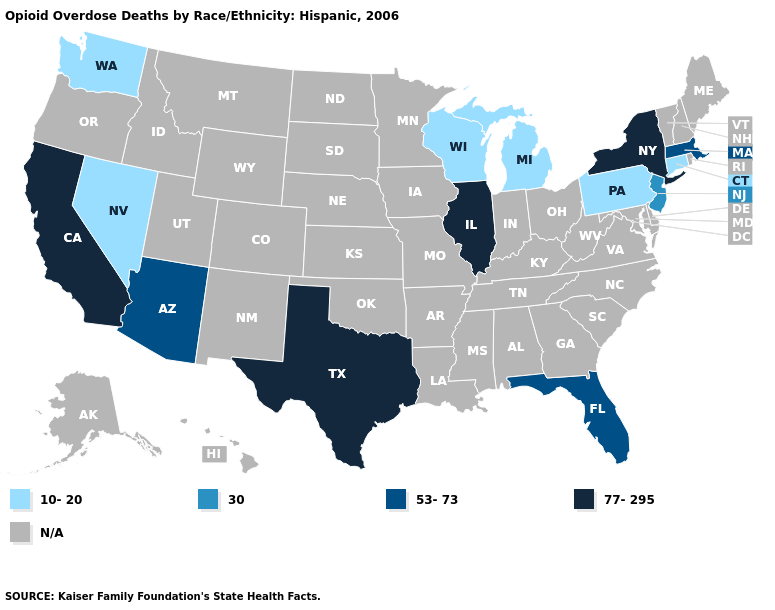What is the value of Wyoming?
Concise answer only. N/A. What is the highest value in the Northeast ?
Concise answer only. 77-295. Does Pennsylvania have the highest value in the USA?
Concise answer only. No. Name the states that have a value in the range 30?
Keep it brief. New Jersey. What is the value of Missouri?
Short answer required. N/A. Which states hav the highest value in the MidWest?
Answer briefly. Illinois. Name the states that have a value in the range 77-295?
Write a very short answer. California, Illinois, New York, Texas. Is the legend a continuous bar?
Write a very short answer. No. What is the highest value in states that border Illinois?
Short answer required. 10-20. Does Washington have the highest value in the USA?
Short answer required. No. Name the states that have a value in the range N/A?
Concise answer only. Alabama, Alaska, Arkansas, Colorado, Delaware, Georgia, Hawaii, Idaho, Indiana, Iowa, Kansas, Kentucky, Louisiana, Maine, Maryland, Minnesota, Mississippi, Missouri, Montana, Nebraska, New Hampshire, New Mexico, North Carolina, North Dakota, Ohio, Oklahoma, Oregon, Rhode Island, South Carolina, South Dakota, Tennessee, Utah, Vermont, Virginia, West Virginia, Wyoming. Does New York have the lowest value in the Northeast?
Give a very brief answer. No. What is the value of Arizona?
Concise answer only. 53-73. What is the value of New Hampshire?
Concise answer only. N/A. 